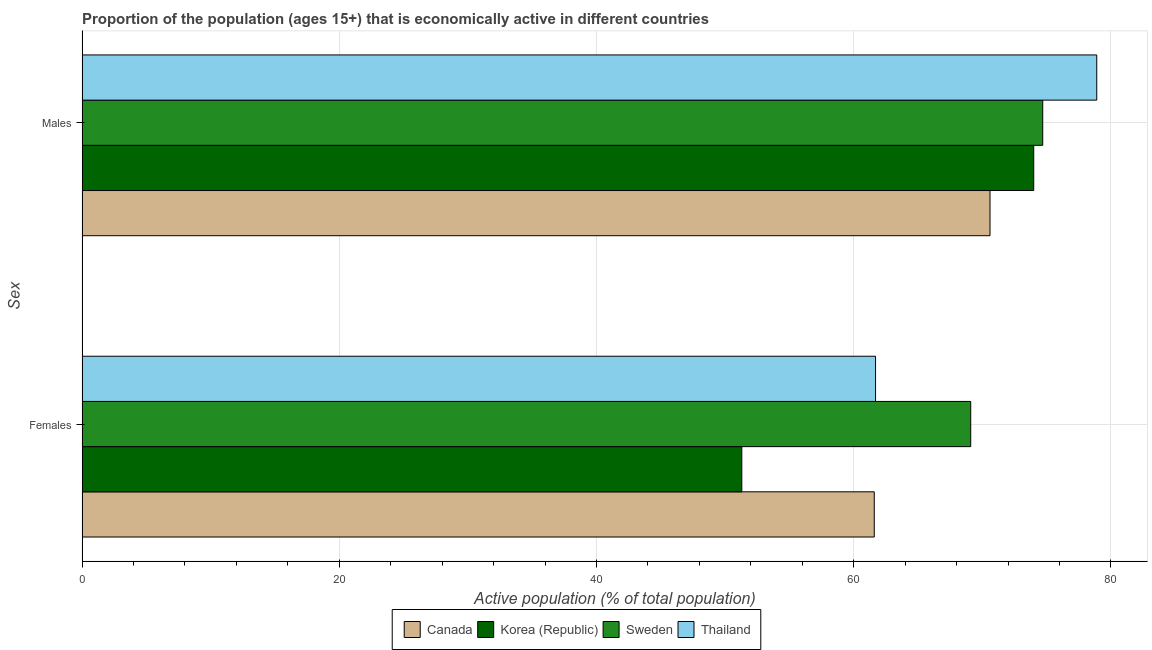Are the number of bars per tick equal to the number of legend labels?
Ensure brevity in your answer.  Yes. How many bars are there on the 2nd tick from the top?
Provide a succinct answer. 4. How many bars are there on the 1st tick from the bottom?
Make the answer very short. 4. What is the label of the 1st group of bars from the top?
Provide a succinct answer. Males. What is the percentage of economically active female population in Thailand?
Offer a terse response. 61.7. Across all countries, what is the maximum percentage of economically active male population?
Your answer should be very brief. 78.9. Across all countries, what is the minimum percentage of economically active female population?
Ensure brevity in your answer.  51.3. In which country was the percentage of economically active female population minimum?
Offer a terse response. Korea (Republic). What is the total percentage of economically active male population in the graph?
Make the answer very short. 298.2. What is the difference between the percentage of economically active male population in Canada and that in Thailand?
Provide a succinct answer. -8.3. What is the difference between the percentage of economically active female population in Korea (Republic) and the percentage of economically active male population in Canada?
Give a very brief answer. -19.3. What is the average percentage of economically active female population per country?
Provide a succinct answer. 60.92. What is the difference between the percentage of economically active male population and percentage of economically active female population in Korea (Republic)?
Offer a very short reply. 22.7. In how many countries, is the percentage of economically active female population greater than 68 %?
Offer a terse response. 1. What is the ratio of the percentage of economically active female population in Korea (Republic) to that in Thailand?
Your response must be concise. 0.83. Is the percentage of economically active female population in Canada less than that in Sweden?
Keep it short and to the point. Yes. In how many countries, is the percentage of economically active female population greater than the average percentage of economically active female population taken over all countries?
Provide a succinct answer. 3. What does the 1st bar from the top in Males represents?
Provide a succinct answer. Thailand. What does the 2nd bar from the bottom in Males represents?
Your response must be concise. Korea (Republic). Are all the bars in the graph horizontal?
Provide a short and direct response. Yes. How many countries are there in the graph?
Provide a short and direct response. 4. Are the values on the major ticks of X-axis written in scientific E-notation?
Provide a succinct answer. No. Does the graph contain any zero values?
Provide a short and direct response. No. Does the graph contain grids?
Ensure brevity in your answer.  Yes. How many legend labels are there?
Make the answer very short. 4. How are the legend labels stacked?
Offer a terse response. Horizontal. What is the title of the graph?
Provide a succinct answer. Proportion of the population (ages 15+) that is economically active in different countries. Does "Papua New Guinea" appear as one of the legend labels in the graph?
Offer a very short reply. No. What is the label or title of the X-axis?
Offer a terse response. Active population (% of total population). What is the label or title of the Y-axis?
Provide a succinct answer. Sex. What is the Active population (% of total population) in Canada in Females?
Provide a succinct answer. 61.6. What is the Active population (% of total population) in Korea (Republic) in Females?
Offer a terse response. 51.3. What is the Active population (% of total population) in Sweden in Females?
Provide a succinct answer. 69.1. What is the Active population (% of total population) of Thailand in Females?
Your answer should be very brief. 61.7. What is the Active population (% of total population) in Canada in Males?
Give a very brief answer. 70.6. What is the Active population (% of total population) of Korea (Republic) in Males?
Keep it short and to the point. 74. What is the Active population (% of total population) in Sweden in Males?
Offer a very short reply. 74.7. What is the Active population (% of total population) in Thailand in Males?
Your answer should be compact. 78.9. Across all Sex, what is the maximum Active population (% of total population) of Canada?
Your answer should be very brief. 70.6. Across all Sex, what is the maximum Active population (% of total population) in Sweden?
Keep it short and to the point. 74.7. Across all Sex, what is the maximum Active population (% of total population) in Thailand?
Keep it short and to the point. 78.9. Across all Sex, what is the minimum Active population (% of total population) of Canada?
Provide a short and direct response. 61.6. Across all Sex, what is the minimum Active population (% of total population) in Korea (Republic)?
Give a very brief answer. 51.3. Across all Sex, what is the minimum Active population (% of total population) in Sweden?
Your response must be concise. 69.1. Across all Sex, what is the minimum Active population (% of total population) in Thailand?
Your answer should be very brief. 61.7. What is the total Active population (% of total population) in Canada in the graph?
Make the answer very short. 132.2. What is the total Active population (% of total population) in Korea (Republic) in the graph?
Keep it short and to the point. 125.3. What is the total Active population (% of total population) in Sweden in the graph?
Provide a short and direct response. 143.8. What is the total Active population (% of total population) of Thailand in the graph?
Your answer should be very brief. 140.6. What is the difference between the Active population (% of total population) in Korea (Republic) in Females and that in Males?
Give a very brief answer. -22.7. What is the difference between the Active population (% of total population) in Thailand in Females and that in Males?
Provide a short and direct response. -17.2. What is the difference between the Active population (% of total population) of Canada in Females and the Active population (% of total population) of Sweden in Males?
Make the answer very short. -13.1. What is the difference between the Active population (% of total population) in Canada in Females and the Active population (% of total population) in Thailand in Males?
Ensure brevity in your answer.  -17.3. What is the difference between the Active population (% of total population) in Korea (Republic) in Females and the Active population (% of total population) in Sweden in Males?
Give a very brief answer. -23.4. What is the difference between the Active population (% of total population) of Korea (Republic) in Females and the Active population (% of total population) of Thailand in Males?
Keep it short and to the point. -27.6. What is the average Active population (% of total population) in Canada per Sex?
Make the answer very short. 66.1. What is the average Active population (% of total population) of Korea (Republic) per Sex?
Keep it short and to the point. 62.65. What is the average Active population (% of total population) in Sweden per Sex?
Your answer should be very brief. 71.9. What is the average Active population (% of total population) in Thailand per Sex?
Ensure brevity in your answer.  70.3. What is the difference between the Active population (% of total population) of Canada and Active population (% of total population) of Korea (Republic) in Females?
Ensure brevity in your answer.  10.3. What is the difference between the Active population (% of total population) in Canada and Active population (% of total population) in Thailand in Females?
Your response must be concise. -0.1. What is the difference between the Active population (% of total population) in Korea (Republic) and Active population (% of total population) in Sweden in Females?
Ensure brevity in your answer.  -17.8. What is the difference between the Active population (% of total population) of Sweden and Active population (% of total population) of Thailand in Females?
Provide a short and direct response. 7.4. What is the difference between the Active population (% of total population) in Canada and Active population (% of total population) in Korea (Republic) in Males?
Ensure brevity in your answer.  -3.4. What is the difference between the Active population (% of total population) in Canada and Active population (% of total population) in Sweden in Males?
Make the answer very short. -4.1. What is the difference between the Active population (% of total population) in Korea (Republic) and Active population (% of total population) in Thailand in Males?
Ensure brevity in your answer.  -4.9. What is the ratio of the Active population (% of total population) of Canada in Females to that in Males?
Ensure brevity in your answer.  0.87. What is the ratio of the Active population (% of total population) of Korea (Republic) in Females to that in Males?
Offer a terse response. 0.69. What is the ratio of the Active population (% of total population) in Sweden in Females to that in Males?
Give a very brief answer. 0.93. What is the ratio of the Active population (% of total population) in Thailand in Females to that in Males?
Provide a short and direct response. 0.78. What is the difference between the highest and the second highest Active population (% of total population) in Canada?
Provide a succinct answer. 9. What is the difference between the highest and the second highest Active population (% of total population) in Korea (Republic)?
Give a very brief answer. 22.7. What is the difference between the highest and the lowest Active population (% of total population) in Korea (Republic)?
Your answer should be compact. 22.7. What is the difference between the highest and the lowest Active population (% of total population) in Thailand?
Offer a terse response. 17.2. 